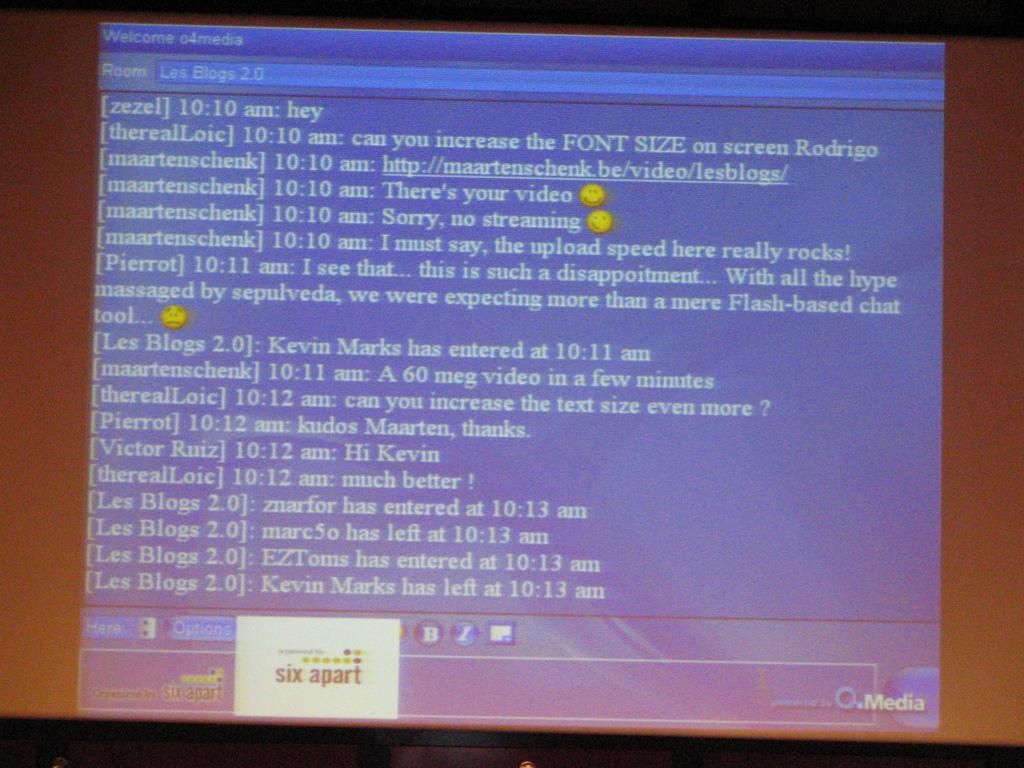<image>
Describe the image concisely. A computer screen shows a dialogue box titled "Welcome o4media" 